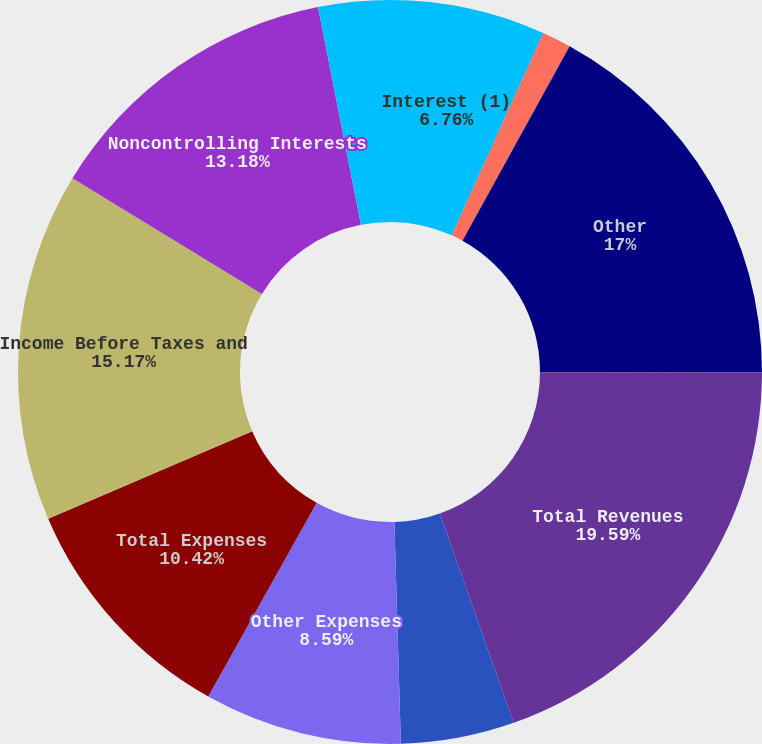<chart> <loc_0><loc_0><loc_500><loc_500><pie_chart><fcel>Interest (1)<fcel>Investment Advisory Fees<fcel>Other<fcel>Total Revenues<fcel>Compensation Expense<fcel>Other Expenses<fcel>Total Expenses<fcel>Income Before Taxes and<fcel>Noncontrolling Interests<fcel>Pre-tax Income Excluding<nl><fcel>6.76%<fcel>1.26%<fcel>17.0%<fcel>19.58%<fcel>4.93%<fcel>8.59%<fcel>10.42%<fcel>15.17%<fcel>13.18%<fcel>3.1%<nl></chart> 